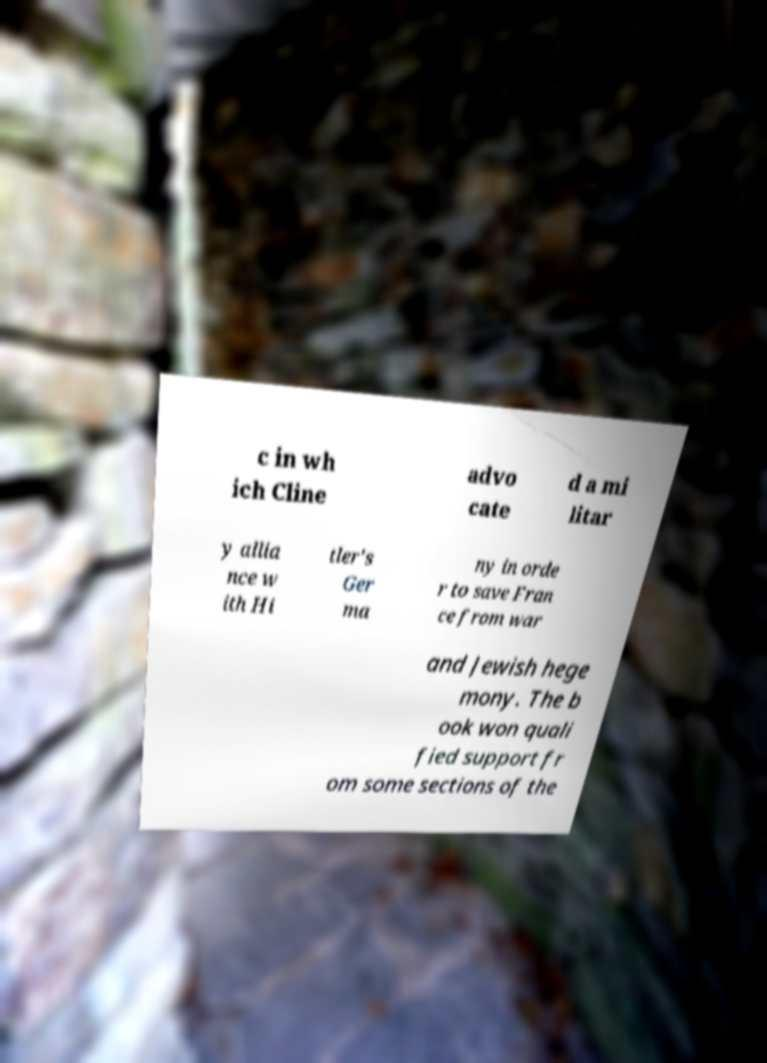For documentation purposes, I need the text within this image transcribed. Could you provide that? c in wh ich Cline advo cate d a mi litar y allia nce w ith Hi tler's Ger ma ny in orde r to save Fran ce from war and Jewish hege mony. The b ook won quali fied support fr om some sections of the 